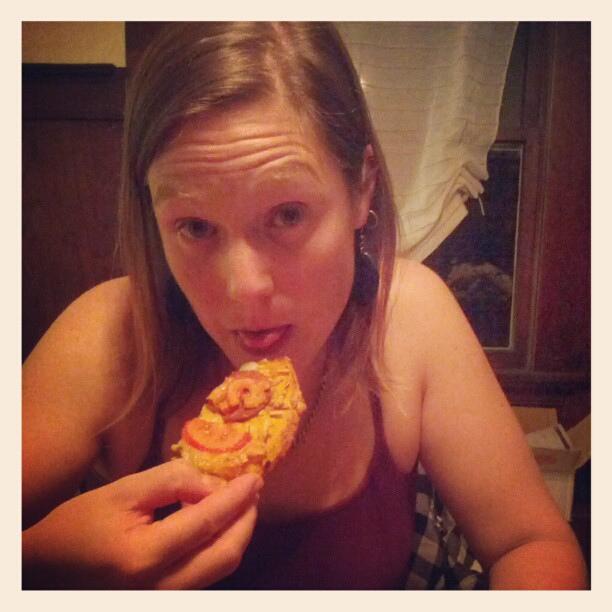What type of pizza is that?
Give a very brief answer. Tomato. Is she wearing earrings?
Give a very brief answer. Yes. Is the woman wearing sunglasses?
Quick response, please. No. What is the woman eating?
Concise answer only. Pizza. What is she eating?
Answer briefly. Pizza. What is on her chest?
Short answer required. Shirt. Is she going to eat that?
Quick response, please. Yes. 